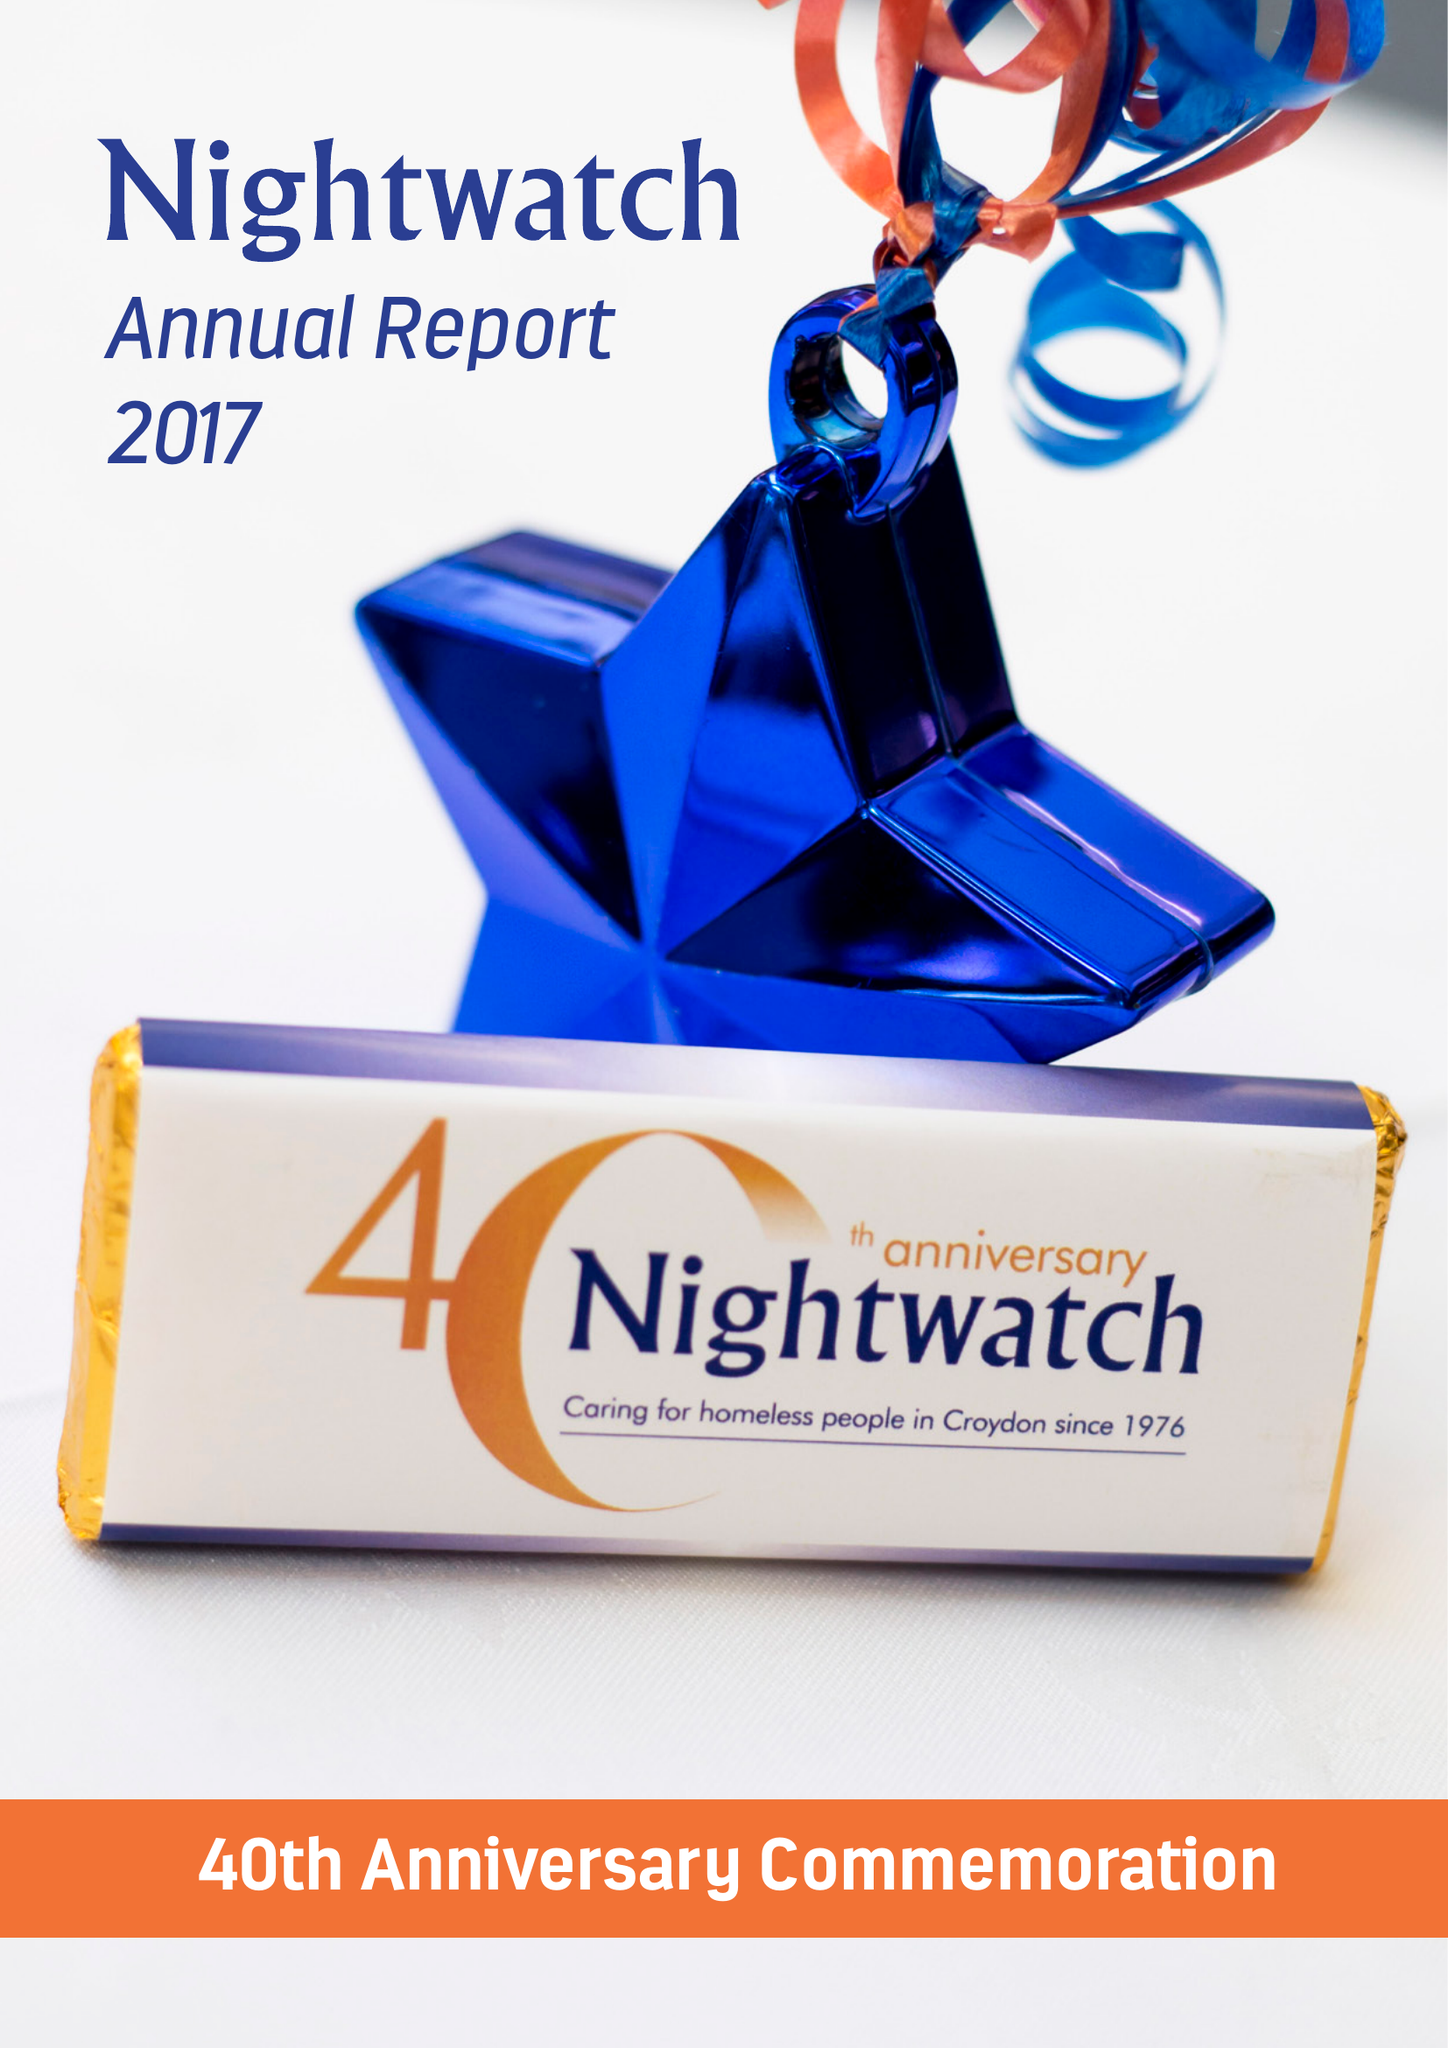What is the value for the charity_number?
Answer the question using a single word or phrase. 274925 